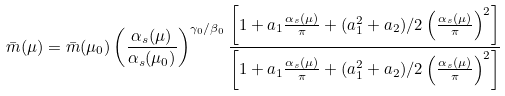Convert formula to latex. <formula><loc_0><loc_0><loc_500><loc_500>\bar { m } ( \mu ) = \bar { m } ( \mu _ { 0 } ) \left ( \frac { \alpha _ { s } ( \mu ) } { \alpha _ { s } ( \mu _ { 0 } ) } \right ) ^ { \gamma _ { 0 } / \beta _ { 0 } } \frac { \left [ 1 + a _ { 1 } \frac { \alpha _ { s } ( \mu ) } { \pi } + ( a _ { 1 } ^ { 2 } + a _ { 2 } ) / 2 \left ( \frac { \alpha _ { s } ( \mu ) } { \pi } \right ) ^ { 2 } \right ] } { \left [ 1 + a _ { 1 } \frac { \alpha _ { s } ( \mu ) } { \pi } + ( a _ { 1 } ^ { 2 } + a _ { 2 } ) / 2 \left ( \frac { \alpha _ { s } ( \mu ) } { \pi } \right ) ^ { 2 } \right ] }</formula> 